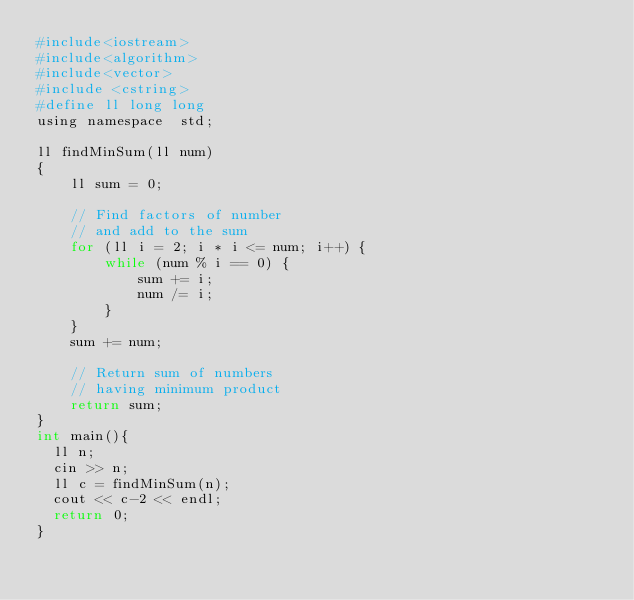Convert code to text. <code><loc_0><loc_0><loc_500><loc_500><_Awk_>#include<iostream>
#include<algorithm>
#include<vector>
#include <cstring> 
#define ll long long
using namespace  std;

ll findMinSum(ll num) 
{ 
    ll sum = 0; 
  
    // Find factors of number 
    // and add to the sum 
    for (ll i = 2; i * i <= num; i++) { 
        while (num % i == 0) { 
            sum += i; 
            num /= i; 
        } 
    } 
    sum += num; 
  
    // Return sum of numbers 
    // having minimum product 
    return sum; 
} 
int main(){
	ll n;
	cin >> n;
	ll c = findMinSum(n);
	cout << c-2 << endl;
	return 0;
}
</code> 